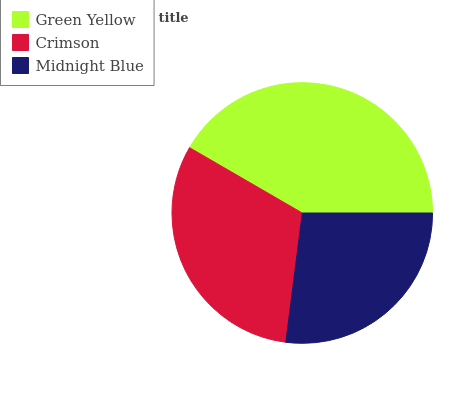Is Midnight Blue the minimum?
Answer yes or no. Yes. Is Green Yellow the maximum?
Answer yes or no. Yes. Is Crimson the minimum?
Answer yes or no. No. Is Crimson the maximum?
Answer yes or no. No. Is Green Yellow greater than Crimson?
Answer yes or no. Yes. Is Crimson less than Green Yellow?
Answer yes or no. Yes. Is Crimson greater than Green Yellow?
Answer yes or no. No. Is Green Yellow less than Crimson?
Answer yes or no. No. Is Crimson the high median?
Answer yes or no. Yes. Is Crimson the low median?
Answer yes or no. Yes. Is Midnight Blue the high median?
Answer yes or no. No. Is Green Yellow the low median?
Answer yes or no. No. 